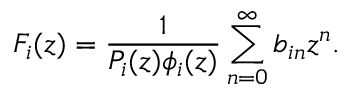Convert formula to latex. <formula><loc_0><loc_0><loc_500><loc_500>F _ { i } ( z ) = { \frac { 1 } { P _ { i } ( z ) \phi _ { i } ( z ) } } \sum _ { n = 0 } ^ { \infty } b _ { i n } z ^ { n } .</formula> 